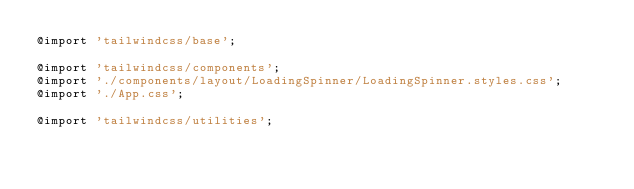Convert code to text. <code><loc_0><loc_0><loc_500><loc_500><_CSS_>@import 'tailwindcss/base';

@import 'tailwindcss/components';
@import './components/layout/LoadingSpinner/LoadingSpinner.styles.css';
@import './App.css';

@import 'tailwindcss/utilities';
</code> 